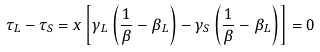<formula> <loc_0><loc_0><loc_500><loc_500>\tau _ { L } - \tau _ { S } = x \left [ \gamma _ { L } \left ( \frac { 1 } { \beta } - \beta _ { L } \right ) - \gamma _ { S } \left ( \frac { 1 } { \beta } - \beta _ { L } \right ) \right ] = 0</formula> 